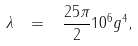<formula> <loc_0><loc_0><loc_500><loc_500>\lambda \, \ = \, \ \frac { 2 5 \pi } { 2 } 1 0 ^ { 6 } g ^ { 4 } ,</formula> 